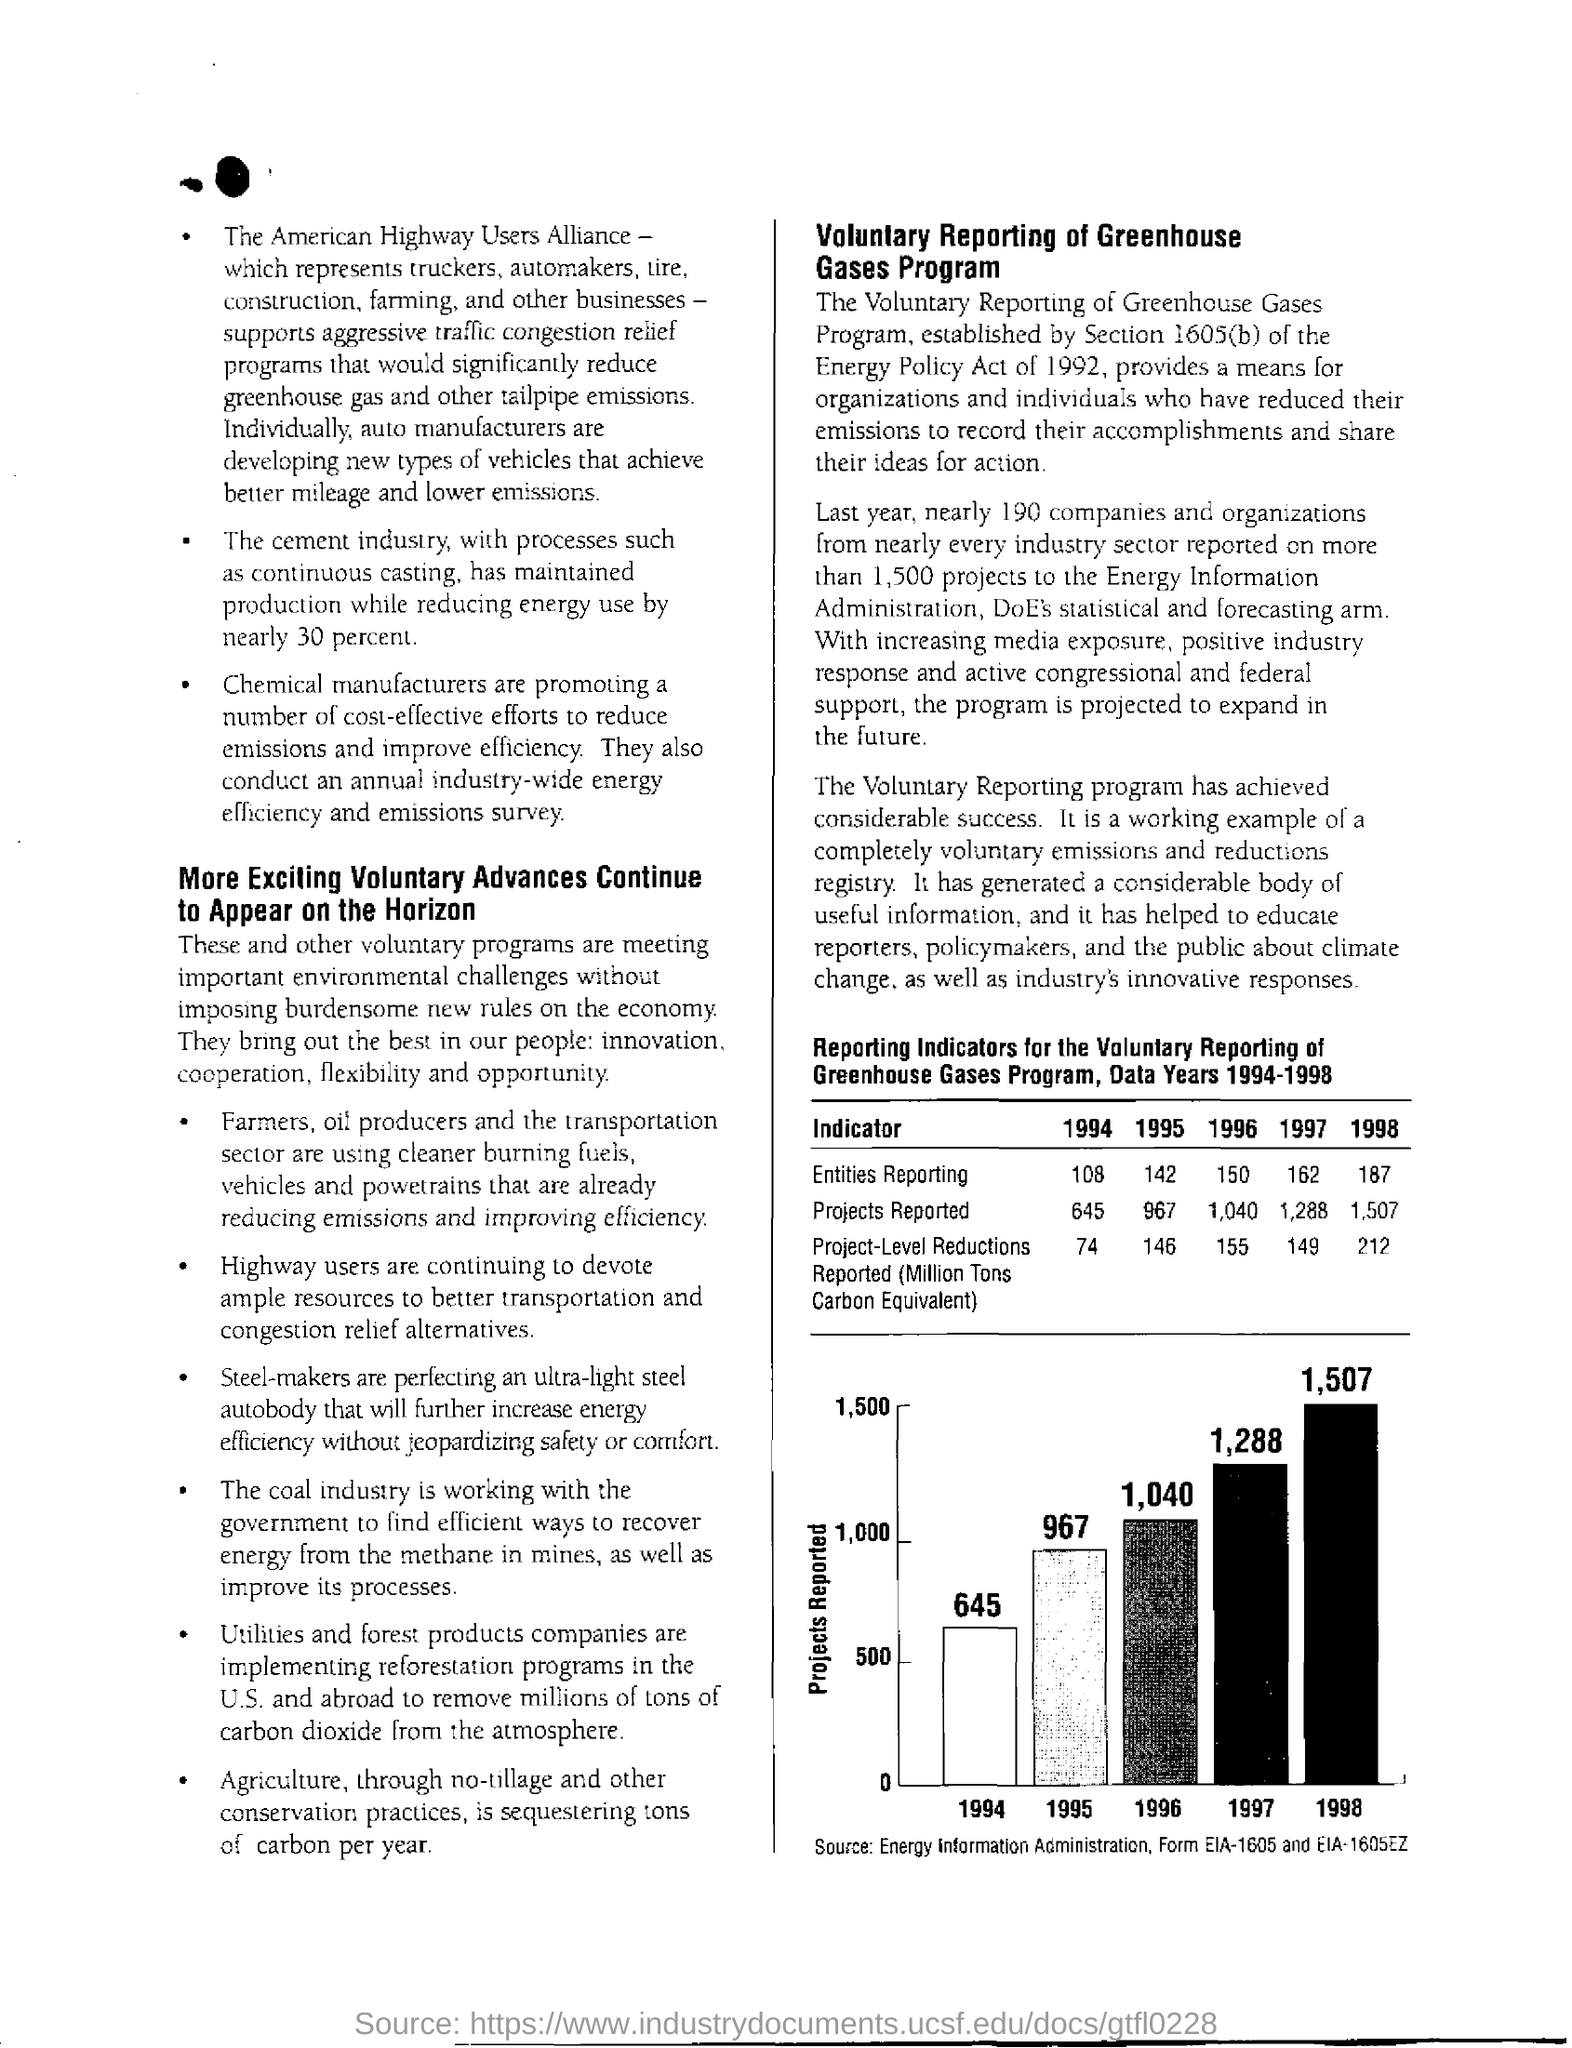By how much has the cement industry reduced energy use?
Offer a very short reply. Nearly 30 percent. What is the source of the bar graph?
Offer a very short reply. Energy Information Administration, form EIA-1605 and EIA-1605EZ. In which year was the most number of projects reported?
Offer a very short reply. 1998. 